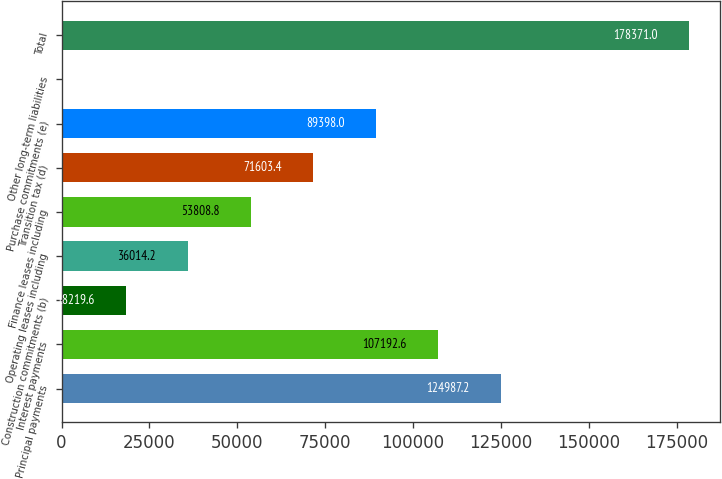Convert chart to OTSL. <chart><loc_0><loc_0><loc_500><loc_500><bar_chart><fcel>Principal payments<fcel>Interest payments<fcel>Construction commitments (b)<fcel>Operating leases including<fcel>Finance leases including<fcel>Transition tax (d)<fcel>Purchase commitments (e)<fcel>Other long-term liabilities<fcel>Total<nl><fcel>124987<fcel>107193<fcel>18219.6<fcel>36014.2<fcel>53808.8<fcel>71603.4<fcel>89398<fcel>425<fcel>178371<nl></chart> 